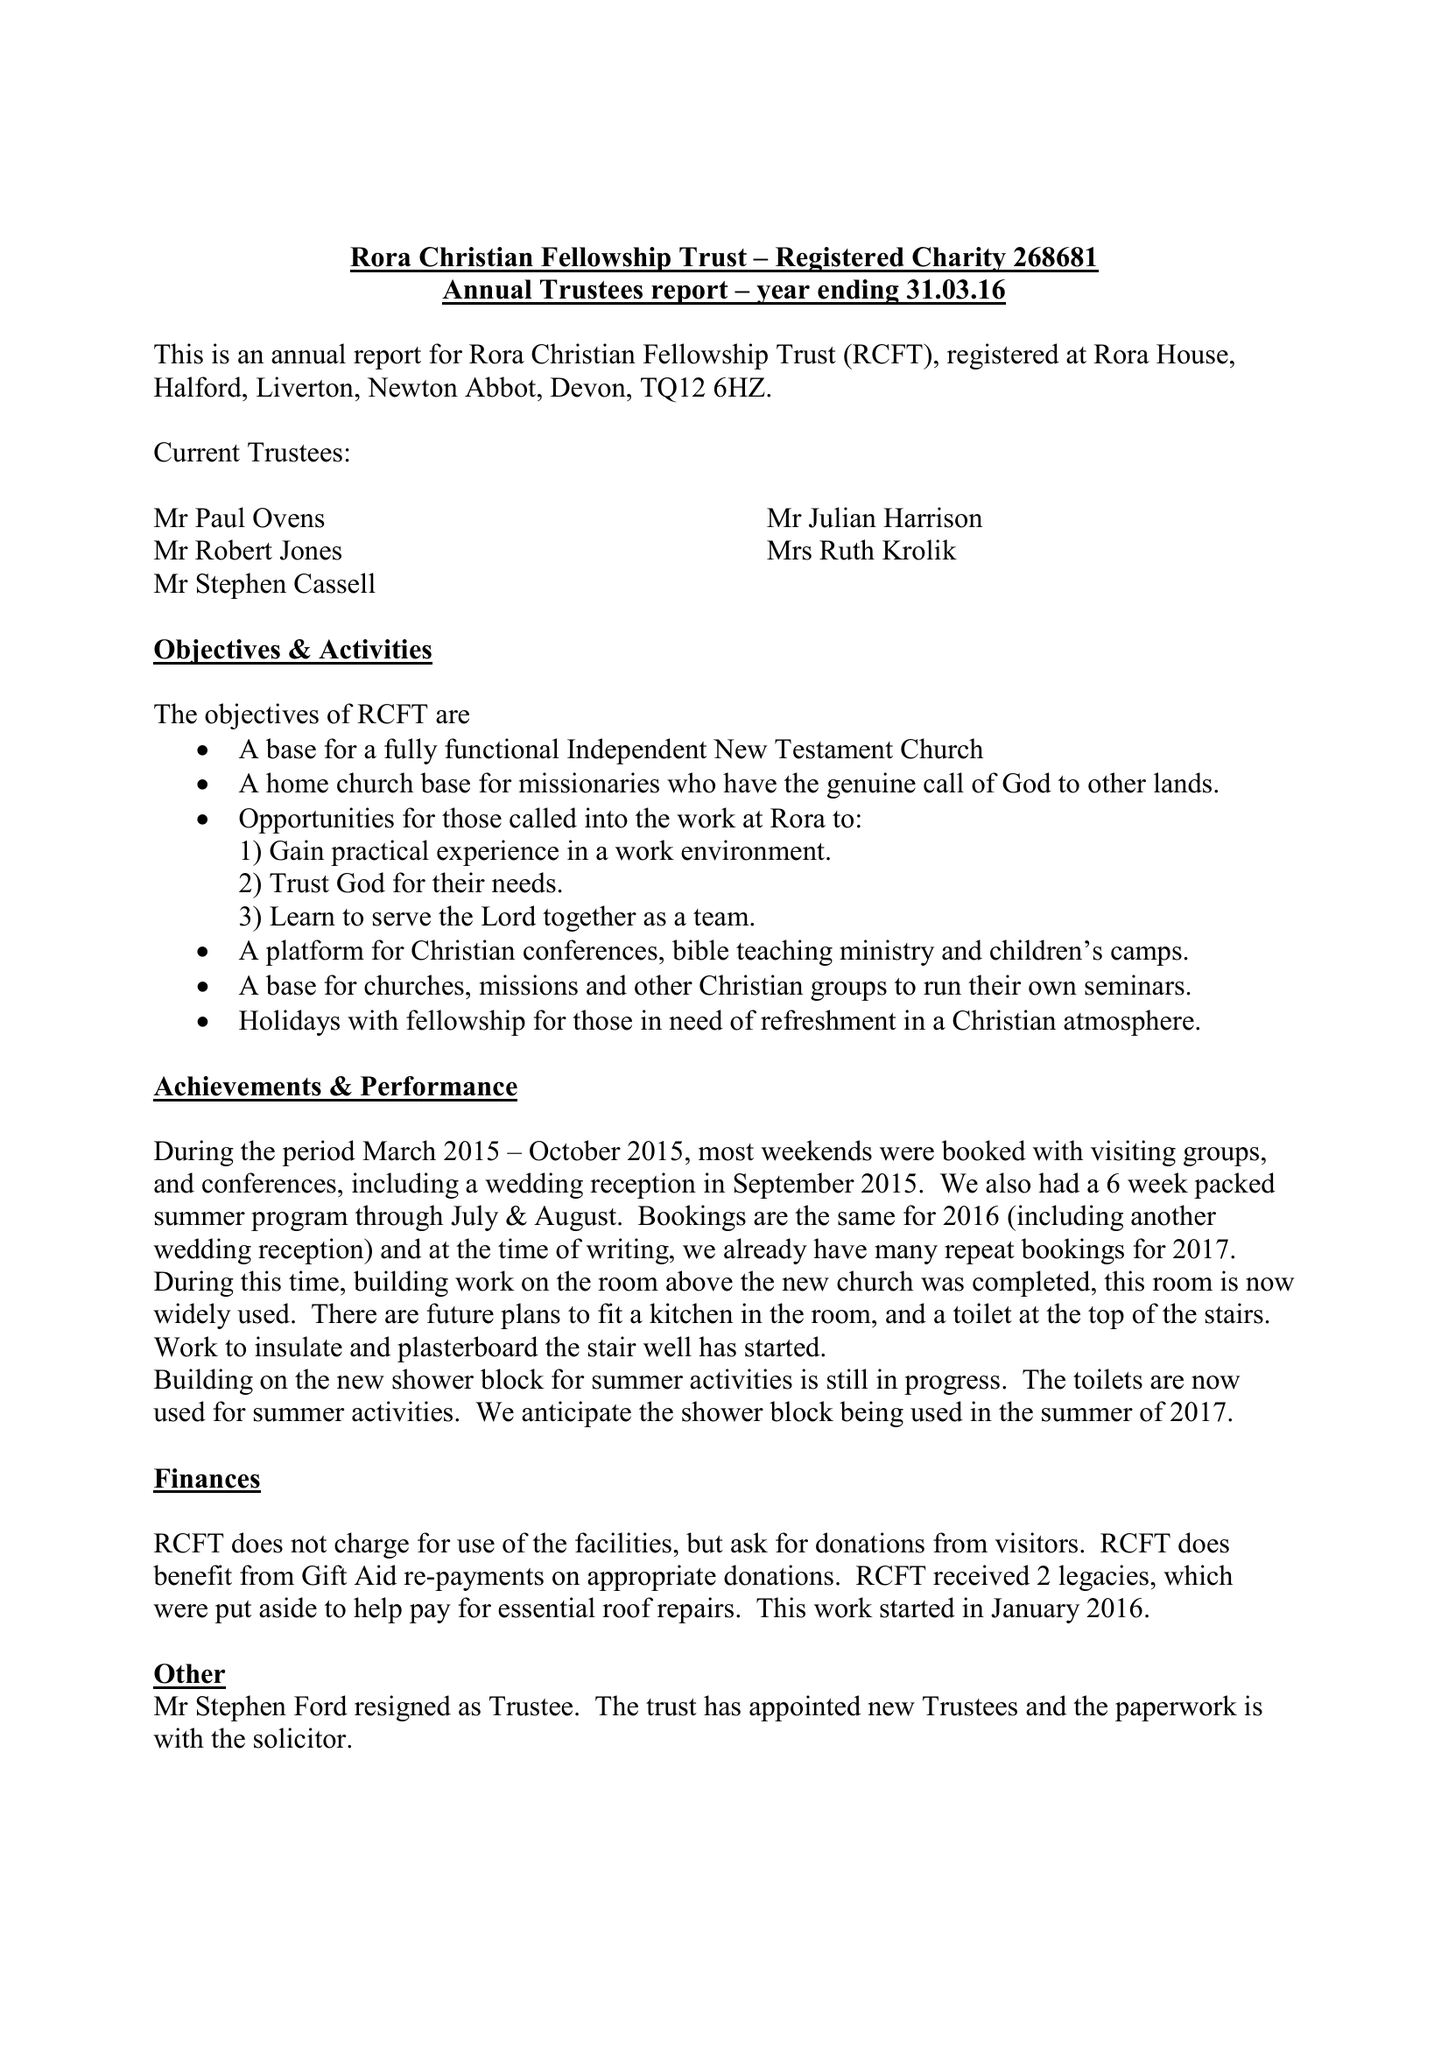What is the value for the report_date?
Answer the question using a single word or phrase. 2016-03-31 